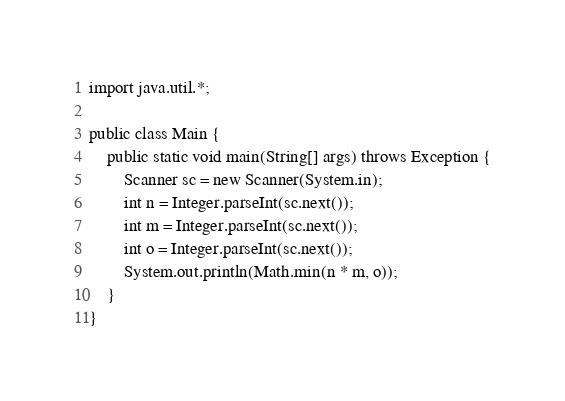<code> <loc_0><loc_0><loc_500><loc_500><_Java_>import java.util.*;

public class Main {
    public static void main(String[] args) throws Exception {
        Scanner sc = new Scanner(System.in);
        int n = Integer.parseInt(sc.next());
        int m = Integer.parseInt(sc.next());
        int o = Integer.parseInt(sc.next());
        System.out.println(Math.min(n * m, o));
    }
}
</code> 